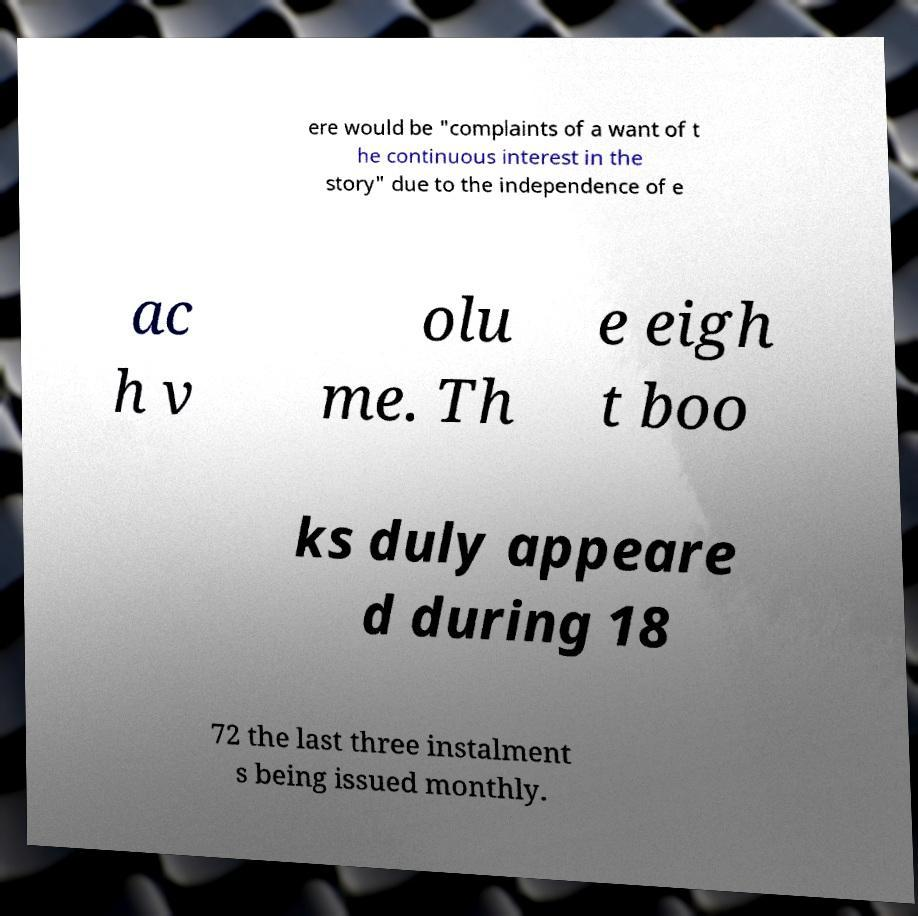There's text embedded in this image that I need extracted. Can you transcribe it verbatim? ere would be "complaints of a want of t he continuous interest in the story" due to the independence of e ac h v olu me. Th e eigh t boo ks duly appeare d during 18 72 the last three instalment s being issued monthly. 